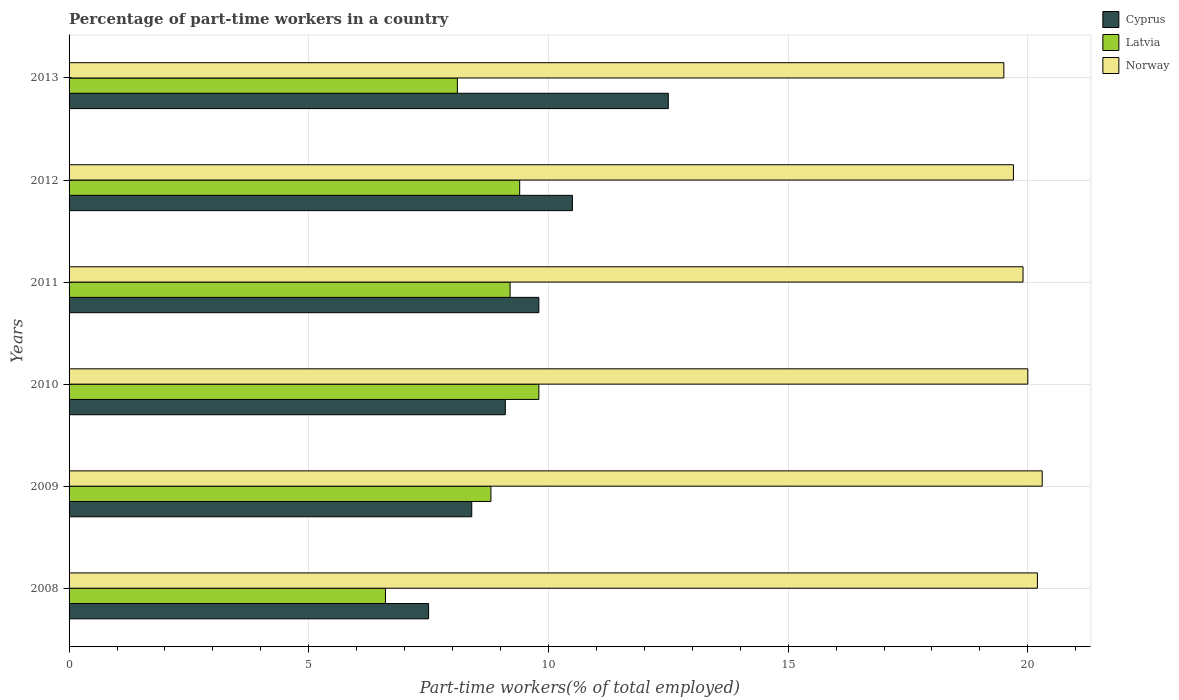How many groups of bars are there?
Provide a short and direct response. 6. Are the number of bars on each tick of the Y-axis equal?
Provide a succinct answer. Yes. How many bars are there on the 4th tick from the top?
Your answer should be compact. 3. What is the label of the 6th group of bars from the top?
Offer a terse response. 2008. What is the percentage of part-time workers in Latvia in 2011?
Provide a short and direct response. 9.2. In which year was the percentage of part-time workers in Cyprus maximum?
Ensure brevity in your answer.  2013. In which year was the percentage of part-time workers in Latvia minimum?
Keep it short and to the point. 2008. What is the total percentage of part-time workers in Cyprus in the graph?
Keep it short and to the point. 57.8. What is the difference between the percentage of part-time workers in Norway in 2010 and that in 2011?
Give a very brief answer. 0.1. What is the difference between the percentage of part-time workers in Cyprus in 2010 and the percentage of part-time workers in Norway in 2012?
Make the answer very short. -10.6. What is the average percentage of part-time workers in Cyprus per year?
Give a very brief answer. 9.63. In the year 2011, what is the difference between the percentage of part-time workers in Cyprus and percentage of part-time workers in Norway?
Ensure brevity in your answer.  -10.1. In how many years, is the percentage of part-time workers in Cyprus greater than 2 %?
Your answer should be compact. 6. What is the ratio of the percentage of part-time workers in Cyprus in 2010 to that in 2013?
Offer a terse response. 0.73. Is the difference between the percentage of part-time workers in Cyprus in 2010 and 2011 greater than the difference between the percentage of part-time workers in Norway in 2010 and 2011?
Provide a short and direct response. No. What is the difference between the highest and the second highest percentage of part-time workers in Latvia?
Your response must be concise. 0.4. What is the difference between the highest and the lowest percentage of part-time workers in Norway?
Offer a very short reply. 0.8. In how many years, is the percentage of part-time workers in Norway greater than the average percentage of part-time workers in Norway taken over all years?
Provide a short and direct response. 3. What does the 3rd bar from the top in 2009 represents?
Your answer should be very brief. Cyprus. What does the 2nd bar from the bottom in 2010 represents?
Offer a terse response. Latvia. Is it the case that in every year, the sum of the percentage of part-time workers in Cyprus and percentage of part-time workers in Norway is greater than the percentage of part-time workers in Latvia?
Provide a succinct answer. Yes. How many bars are there?
Make the answer very short. 18. Are all the bars in the graph horizontal?
Make the answer very short. Yes. What is the difference between two consecutive major ticks on the X-axis?
Provide a short and direct response. 5. Are the values on the major ticks of X-axis written in scientific E-notation?
Make the answer very short. No. Does the graph contain any zero values?
Your response must be concise. No. Where does the legend appear in the graph?
Offer a very short reply. Top right. How many legend labels are there?
Offer a very short reply. 3. What is the title of the graph?
Your response must be concise. Percentage of part-time workers in a country. Does "Indonesia" appear as one of the legend labels in the graph?
Your response must be concise. No. What is the label or title of the X-axis?
Your response must be concise. Part-time workers(% of total employed). What is the Part-time workers(% of total employed) in Latvia in 2008?
Provide a short and direct response. 6.6. What is the Part-time workers(% of total employed) in Norway in 2008?
Make the answer very short. 20.2. What is the Part-time workers(% of total employed) in Cyprus in 2009?
Offer a very short reply. 8.4. What is the Part-time workers(% of total employed) in Latvia in 2009?
Give a very brief answer. 8.8. What is the Part-time workers(% of total employed) in Norway in 2009?
Give a very brief answer. 20.3. What is the Part-time workers(% of total employed) of Cyprus in 2010?
Provide a short and direct response. 9.1. What is the Part-time workers(% of total employed) of Latvia in 2010?
Your answer should be compact. 9.8. What is the Part-time workers(% of total employed) in Norway in 2010?
Your answer should be compact. 20. What is the Part-time workers(% of total employed) of Cyprus in 2011?
Provide a succinct answer. 9.8. What is the Part-time workers(% of total employed) of Latvia in 2011?
Give a very brief answer. 9.2. What is the Part-time workers(% of total employed) in Norway in 2011?
Give a very brief answer. 19.9. What is the Part-time workers(% of total employed) in Latvia in 2012?
Keep it short and to the point. 9.4. What is the Part-time workers(% of total employed) of Norway in 2012?
Provide a succinct answer. 19.7. What is the Part-time workers(% of total employed) of Cyprus in 2013?
Ensure brevity in your answer.  12.5. What is the Part-time workers(% of total employed) in Latvia in 2013?
Your answer should be compact. 8.1. Across all years, what is the maximum Part-time workers(% of total employed) in Latvia?
Make the answer very short. 9.8. Across all years, what is the maximum Part-time workers(% of total employed) in Norway?
Your answer should be very brief. 20.3. Across all years, what is the minimum Part-time workers(% of total employed) in Latvia?
Provide a short and direct response. 6.6. Across all years, what is the minimum Part-time workers(% of total employed) in Norway?
Offer a terse response. 19.5. What is the total Part-time workers(% of total employed) of Cyprus in the graph?
Make the answer very short. 57.8. What is the total Part-time workers(% of total employed) of Latvia in the graph?
Offer a very short reply. 51.9. What is the total Part-time workers(% of total employed) in Norway in the graph?
Your answer should be very brief. 119.6. What is the difference between the Part-time workers(% of total employed) in Cyprus in 2008 and that in 2009?
Provide a short and direct response. -0.9. What is the difference between the Part-time workers(% of total employed) of Latvia in 2008 and that in 2009?
Ensure brevity in your answer.  -2.2. What is the difference between the Part-time workers(% of total employed) in Latvia in 2008 and that in 2010?
Provide a succinct answer. -3.2. What is the difference between the Part-time workers(% of total employed) in Norway in 2008 and that in 2010?
Your answer should be compact. 0.2. What is the difference between the Part-time workers(% of total employed) of Norway in 2008 and that in 2012?
Ensure brevity in your answer.  0.5. What is the difference between the Part-time workers(% of total employed) in Latvia in 2008 and that in 2013?
Give a very brief answer. -1.5. What is the difference between the Part-time workers(% of total employed) of Cyprus in 2009 and that in 2010?
Offer a very short reply. -0.7. What is the difference between the Part-time workers(% of total employed) of Latvia in 2009 and that in 2010?
Offer a terse response. -1. What is the difference between the Part-time workers(% of total employed) of Latvia in 2009 and that in 2011?
Offer a very short reply. -0.4. What is the difference between the Part-time workers(% of total employed) of Norway in 2009 and that in 2011?
Give a very brief answer. 0.4. What is the difference between the Part-time workers(% of total employed) of Latvia in 2009 and that in 2012?
Make the answer very short. -0.6. What is the difference between the Part-time workers(% of total employed) of Norway in 2009 and that in 2012?
Give a very brief answer. 0.6. What is the difference between the Part-time workers(% of total employed) of Cyprus in 2009 and that in 2013?
Keep it short and to the point. -4.1. What is the difference between the Part-time workers(% of total employed) in Norway in 2010 and that in 2012?
Your answer should be very brief. 0.3. What is the difference between the Part-time workers(% of total employed) in Latvia in 2010 and that in 2013?
Ensure brevity in your answer.  1.7. What is the difference between the Part-time workers(% of total employed) in Norway in 2010 and that in 2013?
Give a very brief answer. 0.5. What is the difference between the Part-time workers(% of total employed) in Latvia in 2011 and that in 2012?
Your answer should be compact. -0.2. What is the difference between the Part-time workers(% of total employed) of Cyprus in 2011 and that in 2013?
Keep it short and to the point. -2.7. What is the difference between the Part-time workers(% of total employed) of Latvia in 2011 and that in 2013?
Offer a very short reply. 1.1. What is the difference between the Part-time workers(% of total employed) in Cyprus in 2012 and that in 2013?
Give a very brief answer. -2. What is the difference between the Part-time workers(% of total employed) of Latvia in 2012 and that in 2013?
Give a very brief answer. 1.3. What is the difference between the Part-time workers(% of total employed) of Norway in 2012 and that in 2013?
Ensure brevity in your answer.  0.2. What is the difference between the Part-time workers(% of total employed) of Latvia in 2008 and the Part-time workers(% of total employed) of Norway in 2009?
Ensure brevity in your answer.  -13.7. What is the difference between the Part-time workers(% of total employed) in Cyprus in 2008 and the Part-time workers(% of total employed) in Norway in 2010?
Provide a short and direct response. -12.5. What is the difference between the Part-time workers(% of total employed) of Cyprus in 2008 and the Part-time workers(% of total employed) of Norway in 2011?
Offer a very short reply. -12.4. What is the difference between the Part-time workers(% of total employed) in Latvia in 2008 and the Part-time workers(% of total employed) in Norway in 2011?
Your response must be concise. -13.3. What is the difference between the Part-time workers(% of total employed) of Cyprus in 2008 and the Part-time workers(% of total employed) of Norway in 2012?
Your response must be concise. -12.2. What is the difference between the Part-time workers(% of total employed) in Latvia in 2008 and the Part-time workers(% of total employed) in Norway in 2012?
Offer a very short reply. -13.1. What is the difference between the Part-time workers(% of total employed) in Cyprus in 2009 and the Part-time workers(% of total employed) in Norway in 2010?
Provide a succinct answer. -11.6. What is the difference between the Part-time workers(% of total employed) in Latvia in 2009 and the Part-time workers(% of total employed) in Norway in 2010?
Your response must be concise. -11.2. What is the difference between the Part-time workers(% of total employed) in Cyprus in 2009 and the Part-time workers(% of total employed) in Latvia in 2011?
Your answer should be very brief. -0.8. What is the difference between the Part-time workers(% of total employed) in Latvia in 2009 and the Part-time workers(% of total employed) in Norway in 2011?
Offer a very short reply. -11.1. What is the difference between the Part-time workers(% of total employed) of Cyprus in 2009 and the Part-time workers(% of total employed) of Latvia in 2012?
Your answer should be very brief. -1. What is the difference between the Part-time workers(% of total employed) in Latvia in 2009 and the Part-time workers(% of total employed) in Norway in 2012?
Offer a very short reply. -10.9. What is the difference between the Part-time workers(% of total employed) of Cyprus in 2009 and the Part-time workers(% of total employed) of Norway in 2013?
Give a very brief answer. -11.1. What is the difference between the Part-time workers(% of total employed) of Latvia in 2009 and the Part-time workers(% of total employed) of Norway in 2013?
Offer a very short reply. -10.7. What is the difference between the Part-time workers(% of total employed) in Cyprus in 2010 and the Part-time workers(% of total employed) in Latvia in 2011?
Offer a terse response. -0.1. What is the difference between the Part-time workers(% of total employed) of Cyprus in 2010 and the Part-time workers(% of total employed) of Norway in 2011?
Give a very brief answer. -10.8. What is the difference between the Part-time workers(% of total employed) in Cyprus in 2010 and the Part-time workers(% of total employed) in Latvia in 2013?
Give a very brief answer. 1. What is the difference between the Part-time workers(% of total employed) in Cyprus in 2010 and the Part-time workers(% of total employed) in Norway in 2013?
Keep it short and to the point. -10.4. What is the difference between the Part-time workers(% of total employed) in Latvia in 2010 and the Part-time workers(% of total employed) in Norway in 2013?
Give a very brief answer. -9.7. What is the difference between the Part-time workers(% of total employed) in Cyprus in 2011 and the Part-time workers(% of total employed) in Latvia in 2012?
Make the answer very short. 0.4. What is the difference between the Part-time workers(% of total employed) in Cyprus in 2011 and the Part-time workers(% of total employed) in Norway in 2012?
Your answer should be very brief. -9.9. What is the difference between the Part-time workers(% of total employed) of Cyprus in 2012 and the Part-time workers(% of total employed) of Latvia in 2013?
Give a very brief answer. 2.4. What is the difference between the Part-time workers(% of total employed) of Cyprus in 2012 and the Part-time workers(% of total employed) of Norway in 2013?
Provide a succinct answer. -9. What is the average Part-time workers(% of total employed) of Cyprus per year?
Your answer should be very brief. 9.63. What is the average Part-time workers(% of total employed) of Latvia per year?
Provide a succinct answer. 8.65. What is the average Part-time workers(% of total employed) in Norway per year?
Offer a terse response. 19.93. In the year 2008, what is the difference between the Part-time workers(% of total employed) of Cyprus and Part-time workers(% of total employed) of Latvia?
Your response must be concise. 0.9. In the year 2008, what is the difference between the Part-time workers(% of total employed) of Cyprus and Part-time workers(% of total employed) of Norway?
Offer a very short reply. -12.7. In the year 2008, what is the difference between the Part-time workers(% of total employed) of Latvia and Part-time workers(% of total employed) of Norway?
Provide a short and direct response. -13.6. In the year 2009, what is the difference between the Part-time workers(% of total employed) in Cyprus and Part-time workers(% of total employed) in Latvia?
Ensure brevity in your answer.  -0.4. In the year 2009, what is the difference between the Part-time workers(% of total employed) of Latvia and Part-time workers(% of total employed) of Norway?
Offer a very short reply. -11.5. In the year 2010, what is the difference between the Part-time workers(% of total employed) of Cyprus and Part-time workers(% of total employed) of Latvia?
Give a very brief answer. -0.7. In the year 2011, what is the difference between the Part-time workers(% of total employed) in Cyprus and Part-time workers(% of total employed) in Latvia?
Make the answer very short. 0.6. In the year 2011, what is the difference between the Part-time workers(% of total employed) in Cyprus and Part-time workers(% of total employed) in Norway?
Your answer should be very brief. -10.1. In the year 2012, what is the difference between the Part-time workers(% of total employed) of Cyprus and Part-time workers(% of total employed) of Latvia?
Your answer should be very brief. 1.1. In the year 2012, what is the difference between the Part-time workers(% of total employed) of Cyprus and Part-time workers(% of total employed) of Norway?
Your response must be concise. -9.2. In the year 2012, what is the difference between the Part-time workers(% of total employed) of Latvia and Part-time workers(% of total employed) of Norway?
Give a very brief answer. -10.3. In the year 2013, what is the difference between the Part-time workers(% of total employed) of Cyprus and Part-time workers(% of total employed) of Latvia?
Ensure brevity in your answer.  4.4. In the year 2013, what is the difference between the Part-time workers(% of total employed) of Cyprus and Part-time workers(% of total employed) of Norway?
Offer a very short reply. -7. In the year 2013, what is the difference between the Part-time workers(% of total employed) in Latvia and Part-time workers(% of total employed) in Norway?
Ensure brevity in your answer.  -11.4. What is the ratio of the Part-time workers(% of total employed) in Cyprus in 2008 to that in 2009?
Offer a terse response. 0.89. What is the ratio of the Part-time workers(% of total employed) in Latvia in 2008 to that in 2009?
Offer a terse response. 0.75. What is the ratio of the Part-time workers(% of total employed) in Cyprus in 2008 to that in 2010?
Make the answer very short. 0.82. What is the ratio of the Part-time workers(% of total employed) in Latvia in 2008 to that in 2010?
Your response must be concise. 0.67. What is the ratio of the Part-time workers(% of total employed) in Cyprus in 2008 to that in 2011?
Ensure brevity in your answer.  0.77. What is the ratio of the Part-time workers(% of total employed) in Latvia in 2008 to that in 2011?
Make the answer very short. 0.72. What is the ratio of the Part-time workers(% of total employed) in Norway in 2008 to that in 2011?
Offer a very short reply. 1.02. What is the ratio of the Part-time workers(% of total employed) of Cyprus in 2008 to that in 2012?
Provide a succinct answer. 0.71. What is the ratio of the Part-time workers(% of total employed) of Latvia in 2008 to that in 2012?
Provide a succinct answer. 0.7. What is the ratio of the Part-time workers(% of total employed) in Norway in 2008 to that in 2012?
Keep it short and to the point. 1.03. What is the ratio of the Part-time workers(% of total employed) of Cyprus in 2008 to that in 2013?
Keep it short and to the point. 0.6. What is the ratio of the Part-time workers(% of total employed) of Latvia in 2008 to that in 2013?
Ensure brevity in your answer.  0.81. What is the ratio of the Part-time workers(% of total employed) of Norway in 2008 to that in 2013?
Make the answer very short. 1.04. What is the ratio of the Part-time workers(% of total employed) of Latvia in 2009 to that in 2010?
Provide a short and direct response. 0.9. What is the ratio of the Part-time workers(% of total employed) of Norway in 2009 to that in 2010?
Provide a short and direct response. 1.01. What is the ratio of the Part-time workers(% of total employed) in Cyprus in 2009 to that in 2011?
Make the answer very short. 0.86. What is the ratio of the Part-time workers(% of total employed) in Latvia in 2009 to that in 2011?
Your answer should be compact. 0.96. What is the ratio of the Part-time workers(% of total employed) of Norway in 2009 to that in 2011?
Your answer should be compact. 1.02. What is the ratio of the Part-time workers(% of total employed) in Cyprus in 2009 to that in 2012?
Make the answer very short. 0.8. What is the ratio of the Part-time workers(% of total employed) of Latvia in 2009 to that in 2012?
Offer a terse response. 0.94. What is the ratio of the Part-time workers(% of total employed) of Norway in 2009 to that in 2012?
Offer a terse response. 1.03. What is the ratio of the Part-time workers(% of total employed) of Cyprus in 2009 to that in 2013?
Provide a short and direct response. 0.67. What is the ratio of the Part-time workers(% of total employed) in Latvia in 2009 to that in 2013?
Keep it short and to the point. 1.09. What is the ratio of the Part-time workers(% of total employed) in Norway in 2009 to that in 2013?
Keep it short and to the point. 1.04. What is the ratio of the Part-time workers(% of total employed) of Cyprus in 2010 to that in 2011?
Keep it short and to the point. 0.93. What is the ratio of the Part-time workers(% of total employed) of Latvia in 2010 to that in 2011?
Your response must be concise. 1.07. What is the ratio of the Part-time workers(% of total employed) in Cyprus in 2010 to that in 2012?
Offer a terse response. 0.87. What is the ratio of the Part-time workers(% of total employed) in Latvia in 2010 to that in 2012?
Offer a very short reply. 1.04. What is the ratio of the Part-time workers(% of total employed) of Norway in 2010 to that in 2012?
Provide a short and direct response. 1.02. What is the ratio of the Part-time workers(% of total employed) in Cyprus in 2010 to that in 2013?
Your answer should be compact. 0.73. What is the ratio of the Part-time workers(% of total employed) in Latvia in 2010 to that in 2013?
Offer a terse response. 1.21. What is the ratio of the Part-time workers(% of total employed) in Norway in 2010 to that in 2013?
Ensure brevity in your answer.  1.03. What is the ratio of the Part-time workers(% of total employed) in Latvia in 2011 to that in 2012?
Your answer should be very brief. 0.98. What is the ratio of the Part-time workers(% of total employed) in Norway in 2011 to that in 2012?
Give a very brief answer. 1.01. What is the ratio of the Part-time workers(% of total employed) in Cyprus in 2011 to that in 2013?
Give a very brief answer. 0.78. What is the ratio of the Part-time workers(% of total employed) of Latvia in 2011 to that in 2013?
Provide a short and direct response. 1.14. What is the ratio of the Part-time workers(% of total employed) of Norway in 2011 to that in 2013?
Provide a succinct answer. 1.02. What is the ratio of the Part-time workers(% of total employed) in Cyprus in 2012 to that in 2013?
Offer a very short reply. 0.84. What is the ratio of the Part-time workers(% of total employed) of Latvia in 2012 to that in 2013?
Your answer should be compact. 1.16. What is the ratio of the Part-time workers(% of total employed) of Norway in 2012 to that in 2013?
Offer a terse response. 1.01. What is the difference between the highest and the second highest Part-time workers(% of total employed) in Norway?
Your answer should be compact. 0.1. What is the difference between the highest and the lowest Part-time workers(% of total employed) in Norway?
Offer a very short reply. 0.8. 